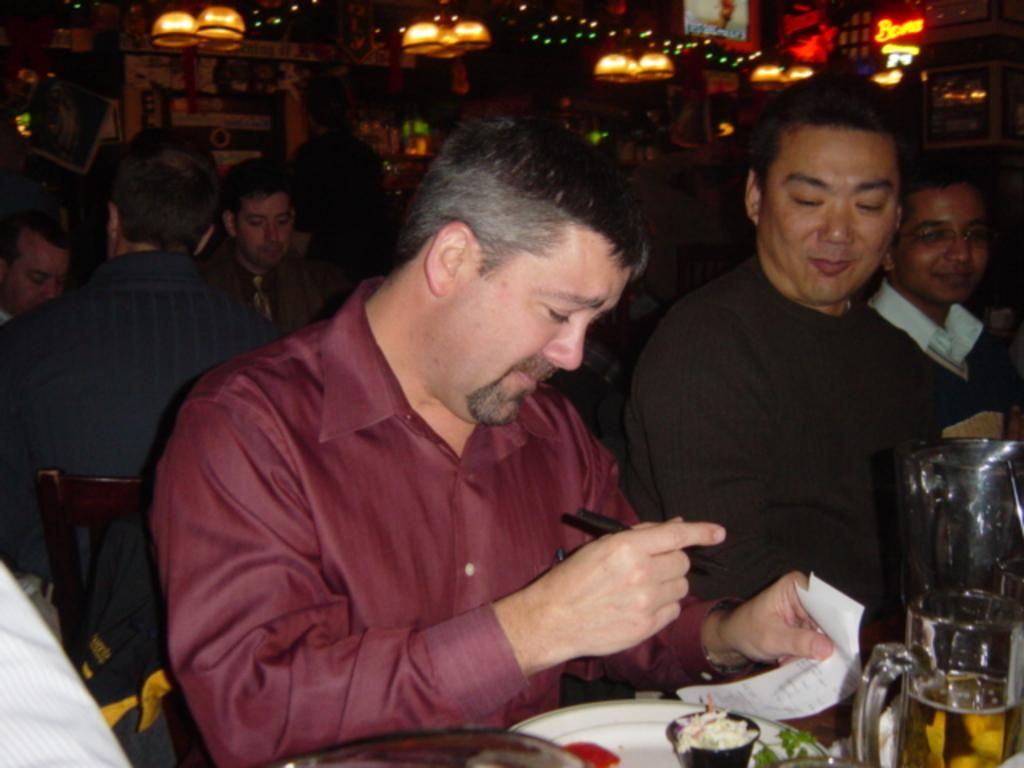How many people are in the image? There is a group of people in the image, but the exact number cannot be determined from the provided facts. What food item is on the plate in the image? The facts do not specify the type of food item on the plate. What type of drink is in the glass in the image? The facts do not specify the type of drink in the glass. What can be seen at the top of the image? There are lights visible at the top of the image. What type of apple is being smashed by the lunchroom monitor in the image? There is no apple or lunchroom monitor present in the image. 